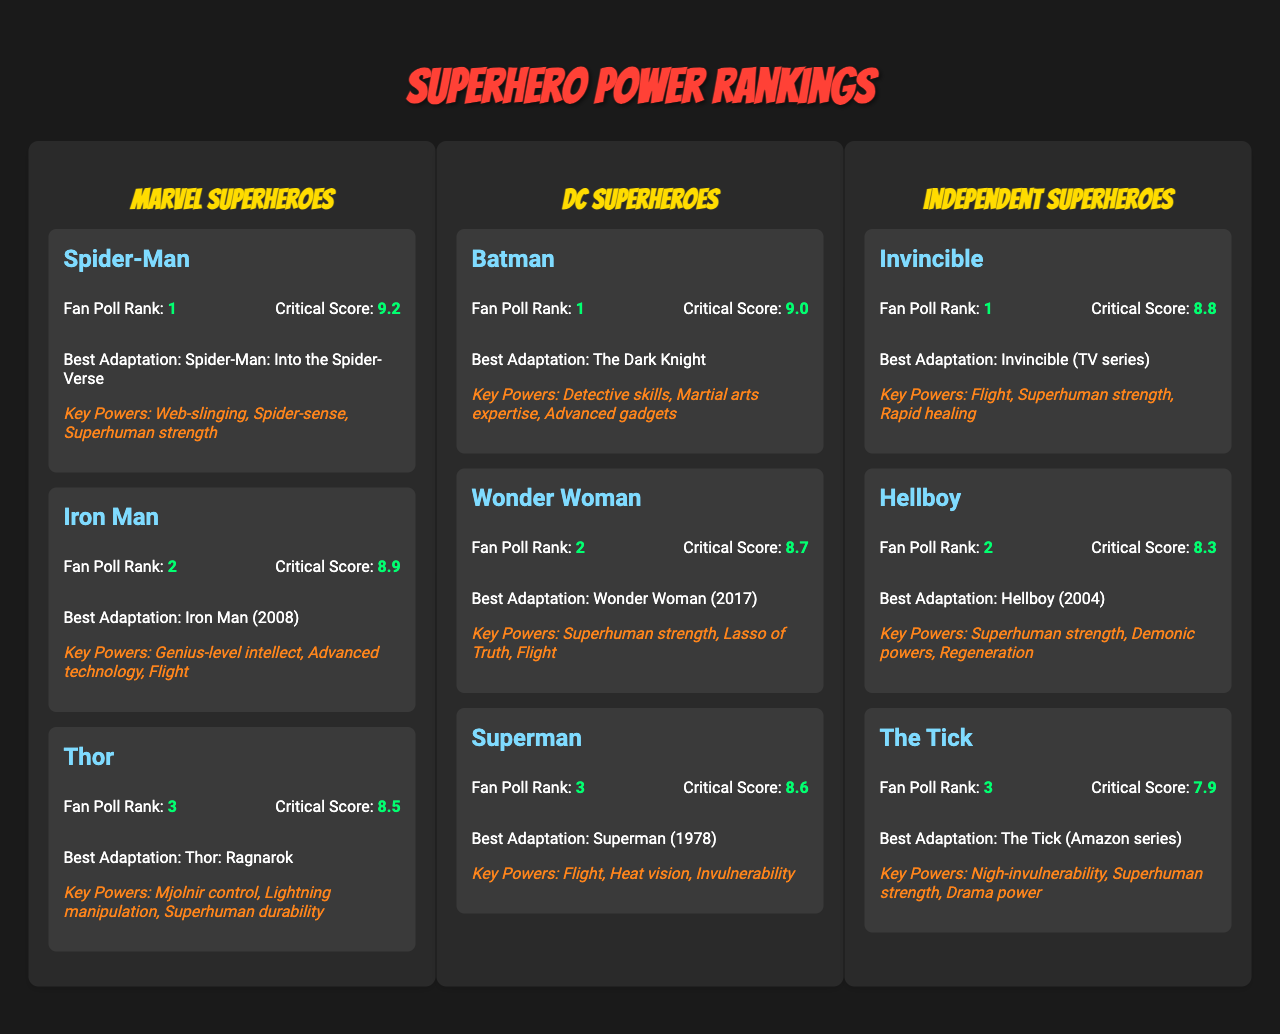What is the highest Critical Review Score among Marvel Superheroes? The Marvel superheroes listed are Spider-Man (9.2), Iron Man (8.9), and Thor (8.5). The highest score is for Spider-Man at 9.2.
Answer: 9.2 Which DC superhero has the lowest Fan Poll Rank? The DC superheroes are Batman (1), Wonder Woman (2), and Superman (3). Superman has the lowest rank of 3.
Answer: Superman Is Iron Man's Most Acclaimed Adaptation better received than Thor's? Iron Man's most acclaimed adaptation is "Iron Man (2008)" and Thor's is "Thor: Ragnarok". Iron Man has a Critical Score of 8.9 while Thor's is 8.5. Since 8.9 is greater than 8.5, Iron Man's adaptation is better received.
Answer: Yes What is the average Fan Poll Rank across all superheroes? The total ranks are 1 (Spider-Man) + 2 (Iron Man) + 3 (Thor) + 1 (Batman) + 2 (Wonder Woman) + 3 (Superman) + 1 (Invincible) + 2 (Hellboy) + 3 (The Tick) = 18. There are 9 superheroes, so the average rank is 18/9 = 2.
Answer: 2 Which superhero has the highest Fan Poll Rank overall? The Fan Poll Ranks for all superheroes are Spider-Man (1), Iron Man (2), Thor (3), Batman (1), Wonder Woman (2), Superman (3), Invincible (1), Hellboy (2), and The Tick (3). Both Spider-Man, Batman, and Invincible have a rank of 1, but Spider-Man appears first in the list.
Answer: Spider-Man Is the Critical Review Score for Invincible higher than Superman's? Invincible has a score of 8.8 while Superman's score is 8.6. Since 8.8 is greater than 8.6, Invincible has a higher score.
Answer: Yes How many superheroes in total received a Critical Review Score above 8.5? The scores above 8.5 are Spider-Man (9.2), Iron Man (8.9), Batman (9.0), Wonder Woman (8.7), and Invincible (8.8). This totals to 5 superheroes.
Answer: 5 Which superhero from the Independent category has the lowest Critical Review Score? The Independent superheroes listed are Invincible (8.8), Hellboy (8.3), and The Tick (7.9). The lowest score is for The Tick at 7.9.
Answer: The Tick What are the Key Powers of Wonder Woman? The Key Powers listed for Wonder Woman are superhuman strength, Lasso of Truth, and flight.
Answer: Superhuman strength, Lasso of Truth, flight If we consider all adaptations, which superhero has the best adaptation based on the Critical Review Score? The superhero adaptations' scores are Spider-Man (9.2), Batman (9.0), Iron Man (8.9), Wonder Woman (8.7), and Invincible (8.8). Spider-Man’s adaptation has the highest score of 9.2.
Answer: Spider-Man Is there any Independent superhero who has a Critical Review Score of 8.5 or higher? The Independent superheroes are Invincible (8.8), Hellboy (8.3), and The Tick (7.9). Invincible is the only one with a score of 8.5 or higher.
Answer: Yes 